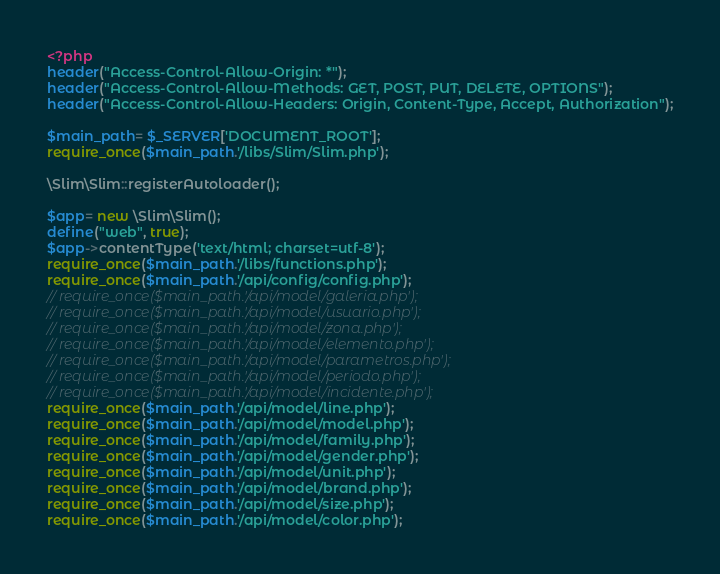<code> <loc_0><loc_0><loc_500><loc_500><_PHP_><?php
header("Access-Control-Allow-Origin: *");
header("Access-Control-Allow-Methods: GET, POST, PUT, DELETE, OPTIONS");
header("Access-Control-Allow-Headers: Origin, Content-Type, Accept, Authorization");

$main_path= $_SERVER['DOCUMENT_ROOT'];
require_once($main_path.'/libs/Slim/Slim.php');

\Slim\Slim::registerAutoloader();

$app= new \Slim\Slim();
define("web", true);
$app->contentType('text/html; charset=utf-8');
require_once($main_path.'/libs/functions.php');
require_once($main_path.'/api/config/config.php');
// require_once($main_path.'/api/model/galeria.php');
// require_once($main_path.'/api/model/usuario.php');
// require_once($main_path.'/api/model/zona.php');
// require_once($main_path.'/api/model/elemento.php');
// require_once($main_path.'/api/model/parametros.php');
// require_once($main_path.'/api/model/periodo.php');
// require_once($main_path.'/api/model/incidente.php');
require_once($main_path.'/api/model/line.php');
require_once($main_path.'/api/model/model.php');
require_once($main_path.'/api/model/family.php');
require_once($main_path.'/api/model/gender.php');
require_once($main_path.'/api/model/unit.php');
require_once($main_path.'/api/model/brand.php');
require_once($main_path.'/api/model/size.php');
require_once($main_path.'/api/model/color.php');</code> 